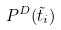<formula> <loc_0><loc_0><loc_500><loc_500>P ^ { D } ( \tilde { t } _ { i } )</formula> 